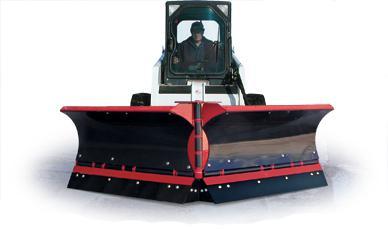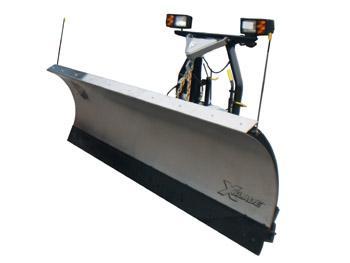The first image is the image on the left, the second image is the image on the right. Given the left and right images, does the statement "One image shows a pickup truck angled facing to the right with a plow attachment in front." hold true? Answer yes or no. No. 